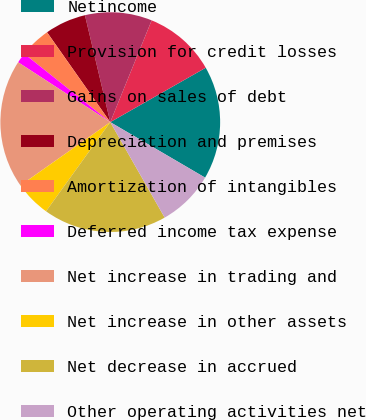Convert chart. <chart><loc_0><loc_0><loc_500><loc_500><pie_chart><fcel>Netincome<fcel>Provision for credit losses<fcel>Gains on sales of debt<fcel>Depreciation and premises<fcel>Amortization of intangibles<fcel>Deferred income tax expense<fcel>Net increase in trading and<fcel>Net increase in other assets<fcel>Net decrease in accrued<fcel>Other operating activities net<nl><fcel>16.67%<fcel>10.61%<fcel>9.85%<fcel>6.06%<fcel>4.55%<fcel>1.52%<fcel>18.94%<fcel>5.3%<fcel>18.18%<fcel>8.33%<nl></chart> 